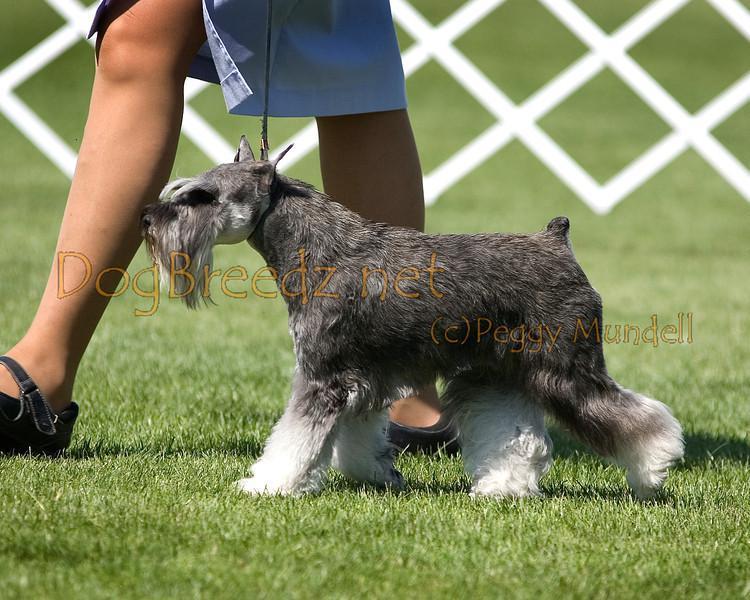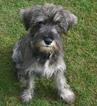The first image is the image on the left, the second image is the image on the right. Examine the images to the left and right. Is the description "The dog in the image on the right is standing up on all four." accurate? Answer yes or no. No. The first image is the image on the left, the second image is the image on the right. For the images shown, is this caption "A schnauzer on a leash is in profile facing leftward in front of some type of white lattice." true? Answer yes or no. Yes. 